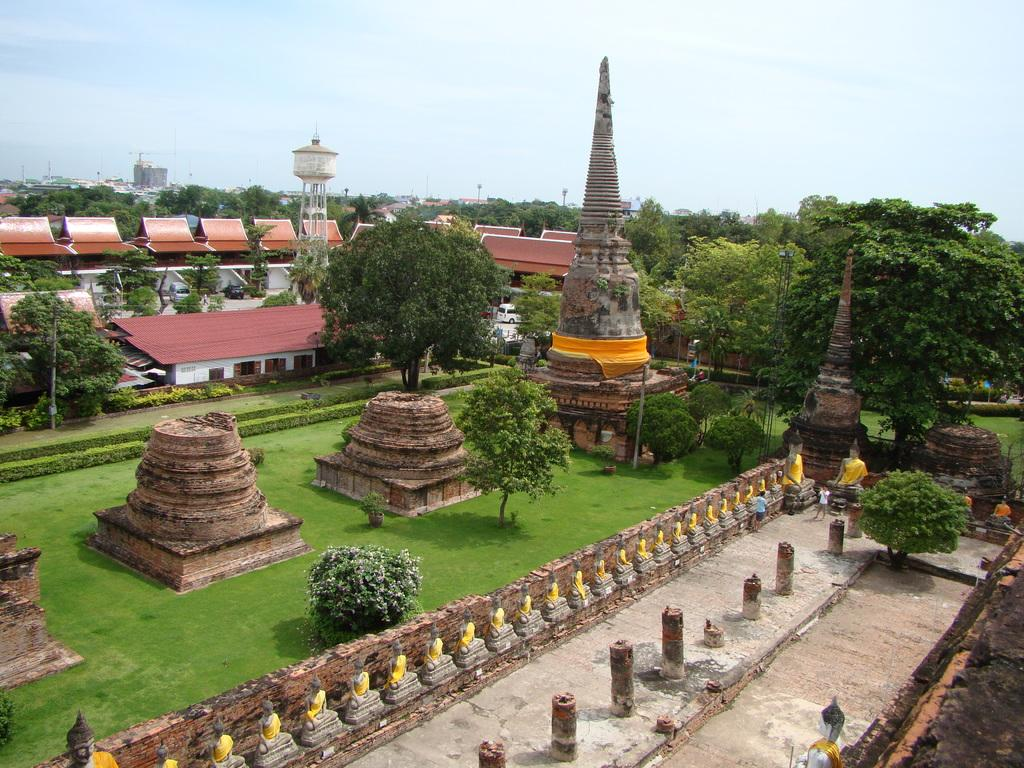What type of structures can be seen in the image? There are statues, poles, houses, towers, and a water tank visible in the image. What type of natural elements are present in the image? There is grass and trees in the image. What type of transportation is visible in the image? There is a vehicle in the image. Are there any people present in the image? Yes, there are people in the image. What type of path can be seen in the image? There is a path in the image. What can be seen in the background of the image? The sky is visible in the background of the image. What verse is being recited by the fireman in the image? There is no fireman or verse present in the image. What type of base is supporting the statues in the image? The statues are not shown with a base in the image. 